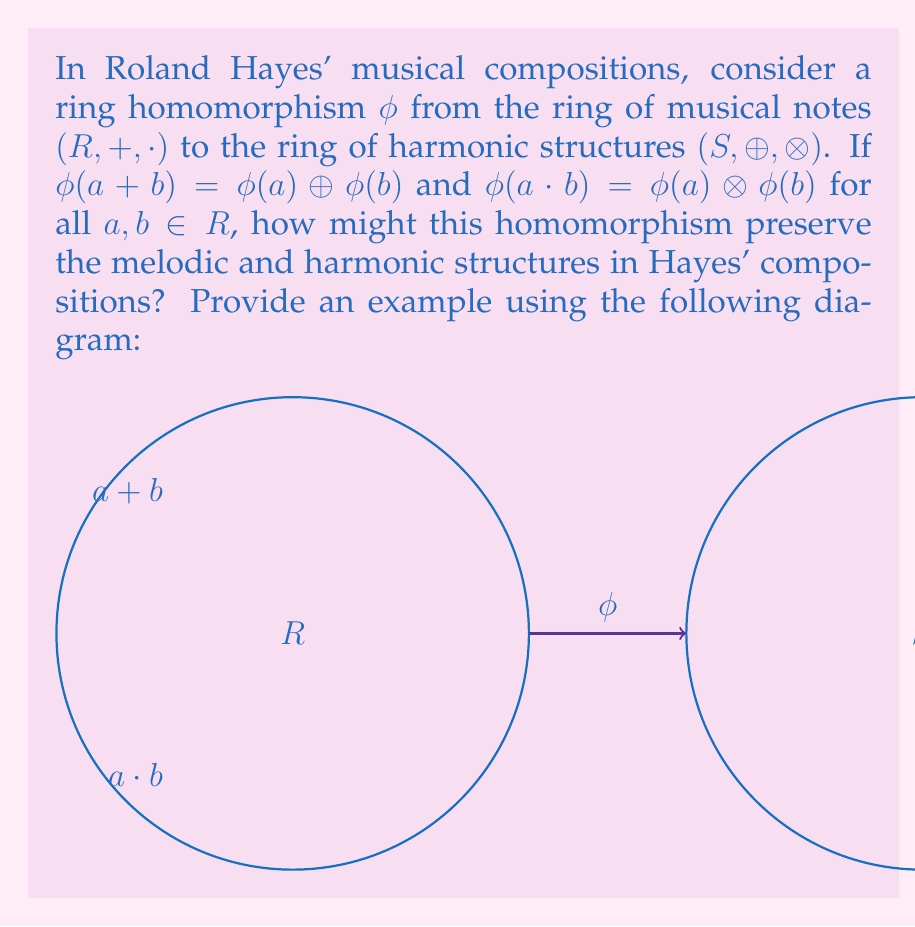Solve this math problem. To understand how the ring homomorphism $\phi$ preserves melodic and harmonic structures in Roland Hayes' compositions, let's break it down step-by-step:

1. Ring structure of musical notes $(R, +, \cdot)$:
   - $+$ represents the combination of notes (melodic structure)
   - $\cdot$ represents the multiplication of notes (harmonic structure)

2. Ring structure of harmonic structures $(S, \oplus, \otimes)$:
   - $\oplus$ represents the combination of harmonic structures
   - $\otimes$ represents the multiplication of harmonic structures

3. Properties of the homomorphism $\phi$:
   a) $\phi(a + b) = \phi(a) \oplus \phi(b)$
   b) $\phi(a \cdot b) = \phi(a) \otimes \phi(b)$

4. Preservation of melodic structure:
   - When Hayes combines two notes $a$ and $b$ in a melody $(a + b)$, the homomorphism maps this to the combination of their corresponding harmonic structures $(\phi(a) \oplus \phi(b))$.
   - This ensures that the melodic relationships in $R$ are preserved in the harmonic structure of $S$.

5. Preservation of harmonic structure:
   - When Hayes creates a harmonic relationship between notes $a$ and $b$ $(a \cdot b)$, the homomorphism maps this to the multiplication of their corresponding harmonic structures $(\phi(a) \otimes \phi(b))$.
   - This ensures that the harmonic relationships in $R$ are preserved in the harmonic structure of $S$.

6. Example:
   Let $a$ represent a C note and $b$ represent an E note in Hayes' composition.
   - Melodic combination: $\phi(C + E) = \phi(C) \oplus \phi(E)$
     This could represent how the individual notes C and E combine to form a melodic interval in the harmonic structure.
   - Harmonic relationship: $\phi(C \cdot E) = \phi(C) \otimes \phi(E)$
     This could represent how C and E form a major third chord in the harmonic structure.

By using this ring homomorphism, Hayes' original musical ideas (in $R$) are consistently translated into complex harmonic structures (in $S$), preserving both melodic and harmonic relationships.
Answer: The homomorphism preserves melodic and harmonic structures by mapping note combinations to harmonic structure combinations $(\phi(a + b) = \phi(a) \oplus \phi(b))$ and note harmonies to harmonic structure multiplications $(\phi(a \cdot b) = \phi(a) \otimes \phi(b))$. 